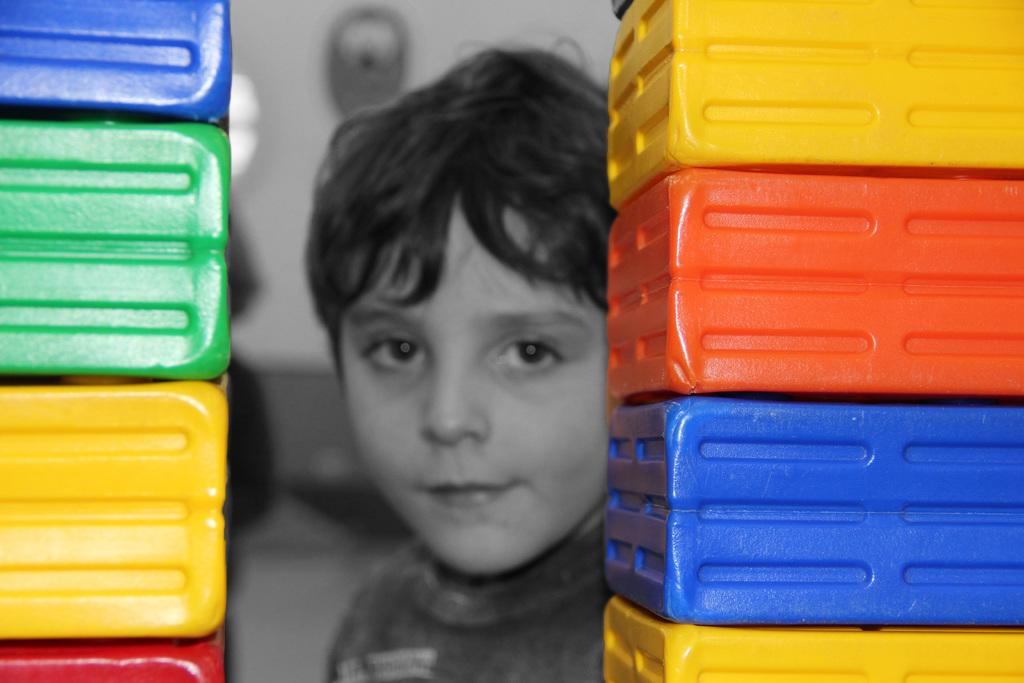What is the main subject of the image? There is a boy in the image. What can be seen on both sides of the boy? There are objects with different colors on both sides of the boy. How would you describe the background of the image? The background of the image is blurred. What is the boy's tendency to use powder in the image? There is no mention of powder or any specific tendencies in the image. 